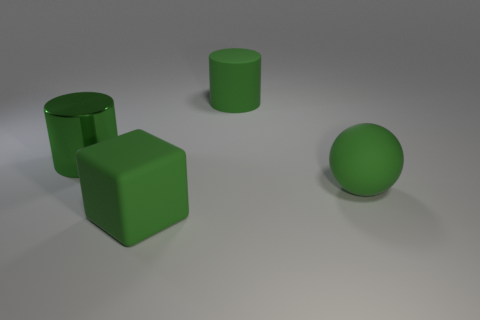Are there any other things that have the same size as the rubber cylinder?
Your response must be concise. Yes. There is another large cylinder that is the same color as the rubber cylinder; what is its material?
Your response must be concise. Metal. There is a block that is the same color as the metal object; what size is it?
Your response must be concise. Large. What material is the cylinder that is to the right of the green rubber object that is left of the green cylinder on the right side of the large green block?
Your answer should be very brief. Rubber. Are there any rubber cubes of the same color as the big matte sphere?
Give a very brief answer. Yes. Is the size of the green object that is to the left of the green block the same as the green rubber cube?
Your answer should be very brief. Yes. How many large things are in front of the matte cylinder and to the left of the large matte ball?
Your answer should be very brief. 2. Are there fewer big green cubes that are behind the big green rubber cylinder than blocks that are behind the large green metal cylinder?
Provide a succinct answer. No. Do the object to the left of the large green block and the cylinder that is right of the large green cube have the same color?
Offer a very short reply. Yes. What is the thing that is in front of the big green metal object and on the right side of the big rubber block made of?
Your answer should be compact. Rubber. 